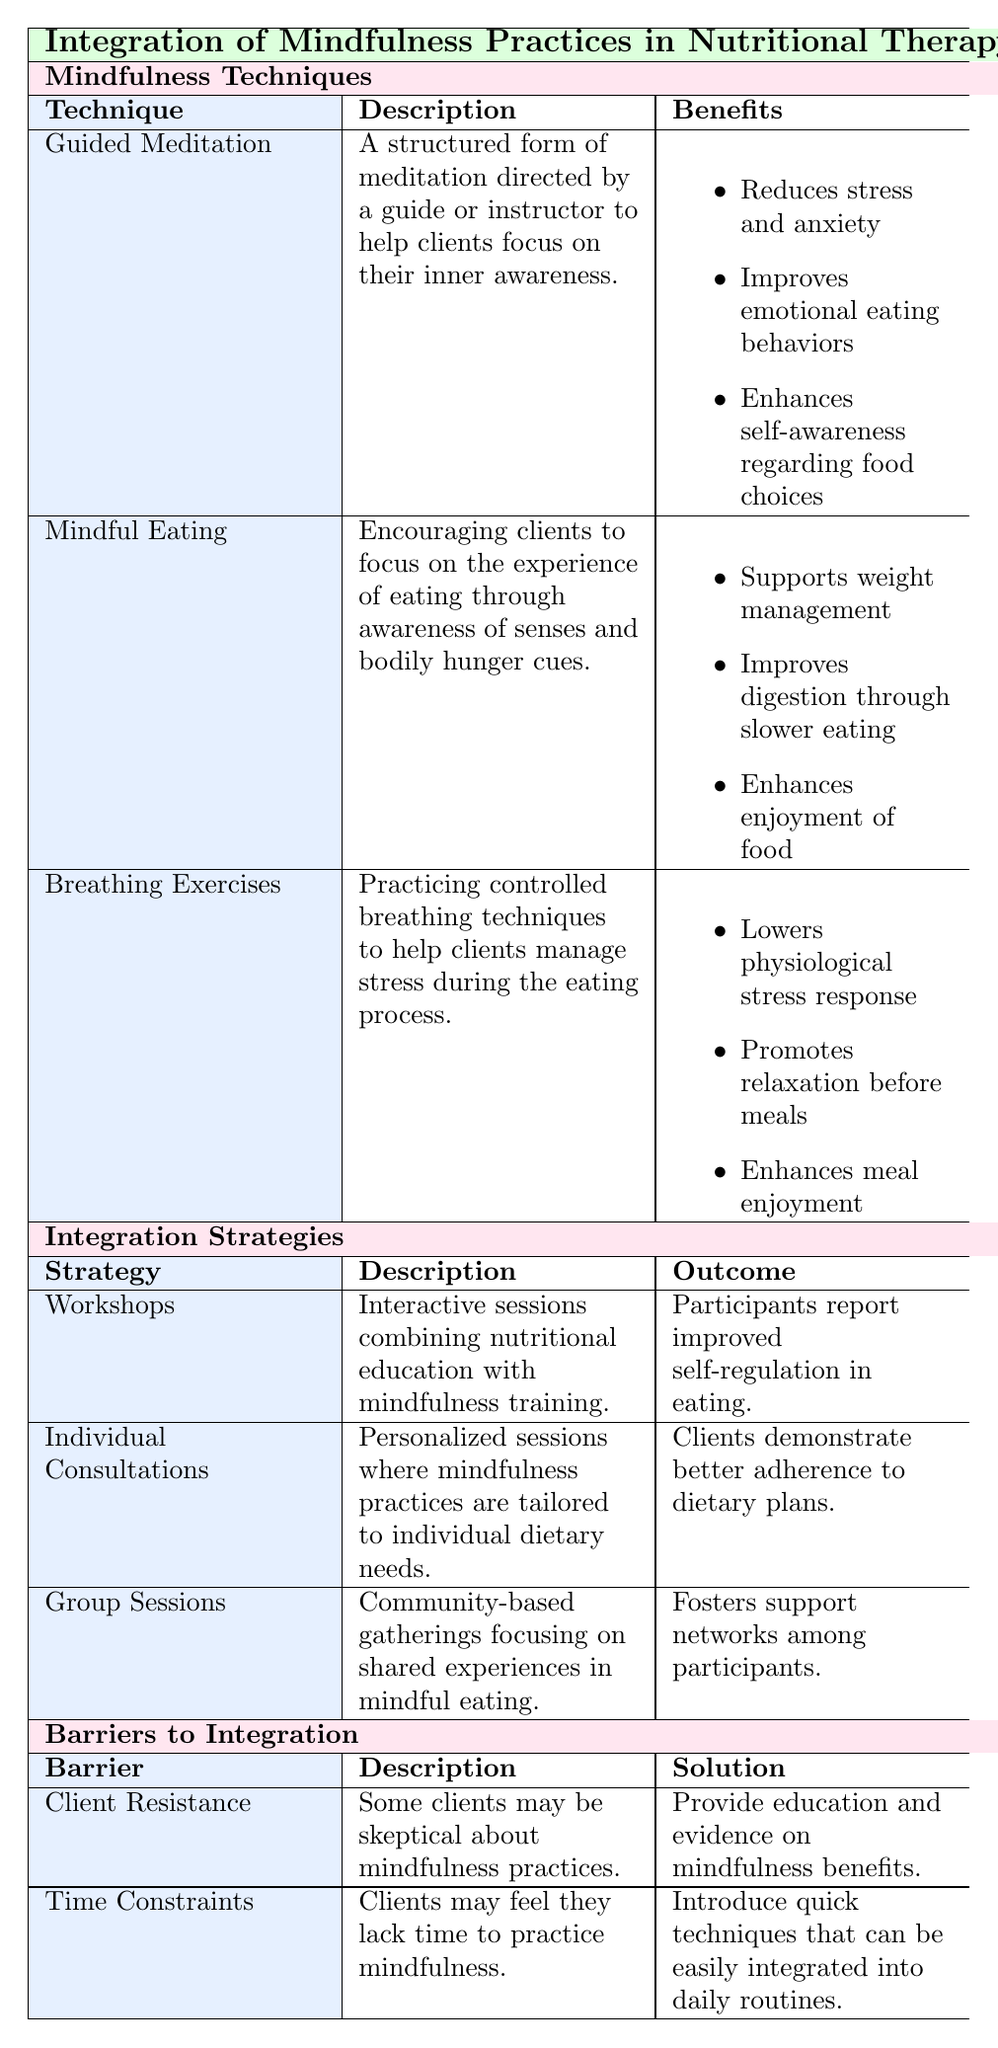What are the benefits of Guided Meditation? According to the table, the benefits of Guided Meditation include reducing stress and anxiety, improving emotional eating behaviors, and enhancing self-awareness regarding food choices. These points can be found in the section detailing the benefits of this specific mindfulness technique.
Answer: Reduces stress and anxiety, improves emotional eating behaviors, enhances self-awareness regarding food choices What does Mindful Eating encourage clients to focus on? The table states that Mindful Eating encourages clients to focus on the experience of eating through awareness of senses and bodily hunger cues. This is clearly indicated in the description of the Mindful Eating technique.
Answer: Awareness of senses and bodily hunger cues Is Breathing Exercises effective for promoting relaxation before meals? Yes, the table specifies that Breathing Exercises promote relaxation before meals as one of the benefits listed under this technique.
Answer: Yes How many outcomes are listed for the Individual Consultations strategy? The table shows that the Individual Consultations strategy has one outcome: that clients demonstrate better adherence to dietary plans. This is directly reported in the corresponding outcome column for this strategy.
Answer: One outcome What are the major barriers to integrating mindfulness practices? The major barriers include Client Resistance and Time Constraints, as detailed in the table under the barriers section. These barriers are clearly labeled and described.
Answer: Client Resistance and Time Constraints If a workshop combines nutritional education with mindfulness training, what is the expected outcome? The expected outcome stated in the table for workshops is that participants report improved self-regulation in eating. This is found in the outcome column corresponding to the Workshops integration strategy.
Answer: Participants report improved self-regulation in eating What is the solution provided to overcome Client Resistance? The table indicates that the solution to overcome Client Resistance is to provide education and evidence on mindfulness benefits, which is listed in the barriers section.
Answer: Provide education and evidence on mindfulness benefits How did the findings from Mason et al. (2016) support the concept of Mindful Eating? The findings from Mason et al. (2016) state that Mindful Eating increased satiety and reduced overall caloric intake in participants. This connects the practice of Mindful Eating to practical benefits that support its implementation in nutritional therapy.
Answer: Increased satiety and reduced overall caloric intake How does the solution for Time Constraints help clients integrate mindfulness? The solution for Time Constraints involves introducing quick techniques that can be easily integrated into daily routines. This suggests that the focus is on making mindfulness more accessible, easing concerns about time during the integration of these practices into daily life.
Answer: Introduce quick techniques 